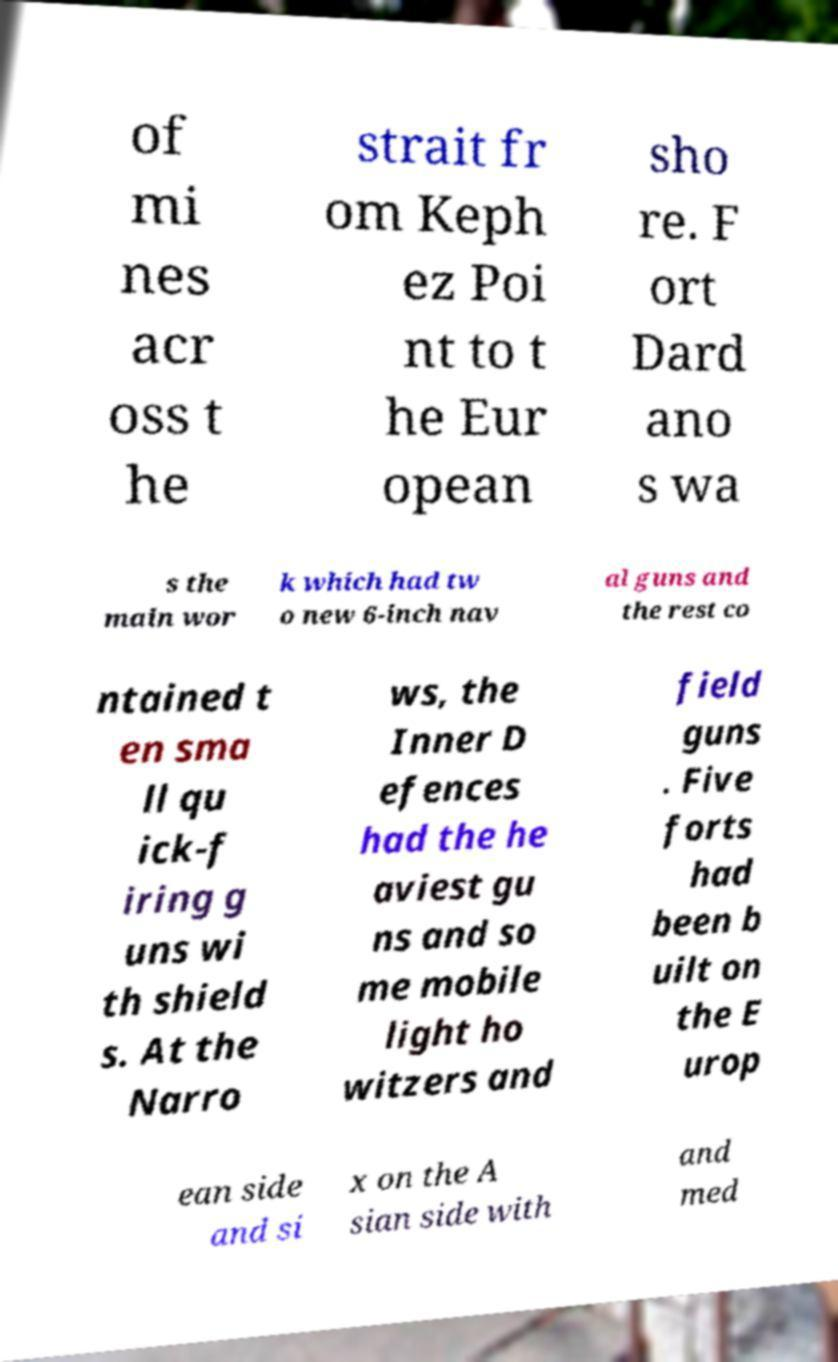Can you read and provide the text displayed in the image?This photo seems to have some interesting text. Can you extract and type it out for me? of mi nes acr oss t he strait fr om Keph ez Poi nt to t he Eur opean sho re. F ort Dard ano s wa s the main wor k which had tw o new 6-inch nav al guns and the rest co ntained t en sma ll qu ick-f iring g uns wi th shield s. At the Narro ws, the Inner D efences had the he aviest gu ns and so me mobile light ho witzers and field guns . Five forts had been b uilt on the E urop ean side and si x on the A sian side with and med 